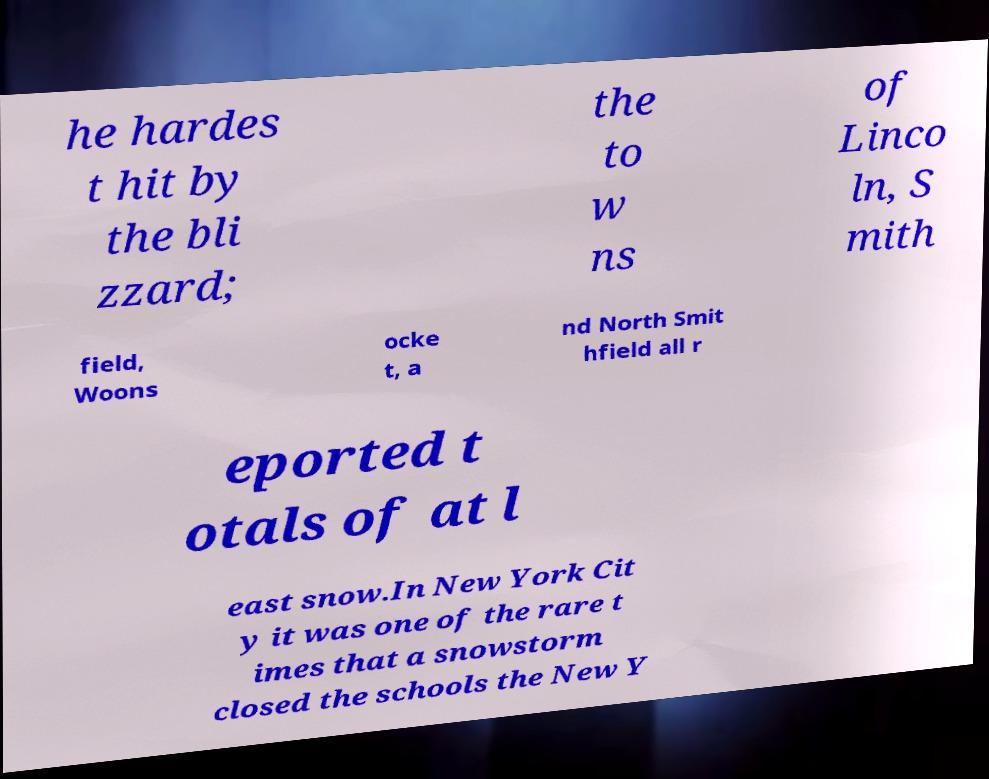Please identify and transcribe the text found in this image. he hardes t hit by the bli zzard; the to w ns of Linco ln, S mith field, Woons ocke t, a nd North Smit hfield all r eported t otals of at l east snow.In New York Cit y it was one of the rare t imes that a snowstorm closed the schools the New Y 